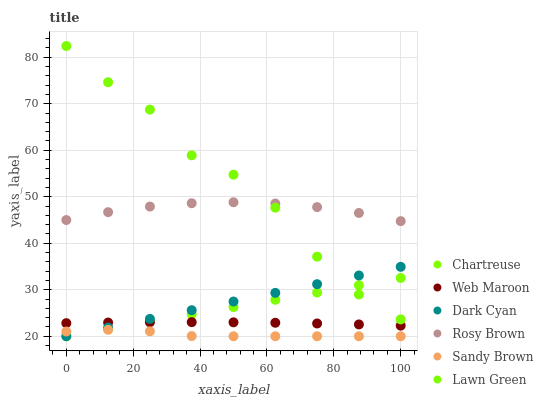Does Sandy Brown have the minimum area under the curve?
Answer yes or no. Yes. Does Lawn Green have the maximum area under the curve?
Answer yes or no. Yes. Does Rosy Brown have the minimum area under the curve?
Answer yes or no. No. Does Rosy Brown have the maximum area under the curve?
Answer yes or no. No. Is Chartreuse the smoothest?
Answer yes or no. Yes. Is Lawn Green the roughest?
Answer yes or no. Yes. Is Rosy Brown the smoothest?
Answer yes or no. No. Is Rosy Brown the roughest?
Answer yes or no. No. Does Chartreuse have the lowest value?
Answer yes or no. Yes. Does Web Maroon have the lowest value?
Answer yes or no. No. Does Lawn Green have the highest value?
Answer yes or no. Yes. Does Rosy Brown have the highest value?
Answer yes or no. No. Is Sandy Brown less than Lawn Green?
Answer yes or no. Yes. Is Web Maroon greater than Sandy Brown?
Answer yes or no. Yes. Does Rosy Brown intersect Lawn Green?
Answer yes or no. Yes. Is Rosy Brown less than Lawn Green?
Answer yes or no. No. Is Rosy Brown greater than Lawn Green?
Answer yes or no. No. Does Sandy Brown intersect Lawn Green?
Answer yes or no. No. 